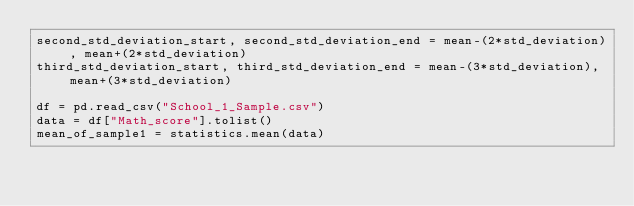Convert code to text. <code><loc_0><loc_0><loc_500><loc_500><_Python_>second_std_deviation_start, second_std_deviation_end = mean-(2*std_deviation), mean+(2*std_deviation)
third_std_deviation_start, third_std_deviation_end = mean-(3*std_deviation), mean+(3*std_deviation)

df = pd.read_csv("School_1_Sample.csv")
data = df["Math_score"].tolist()
mean_of_sample1 = statistics.mean(data)</code> 